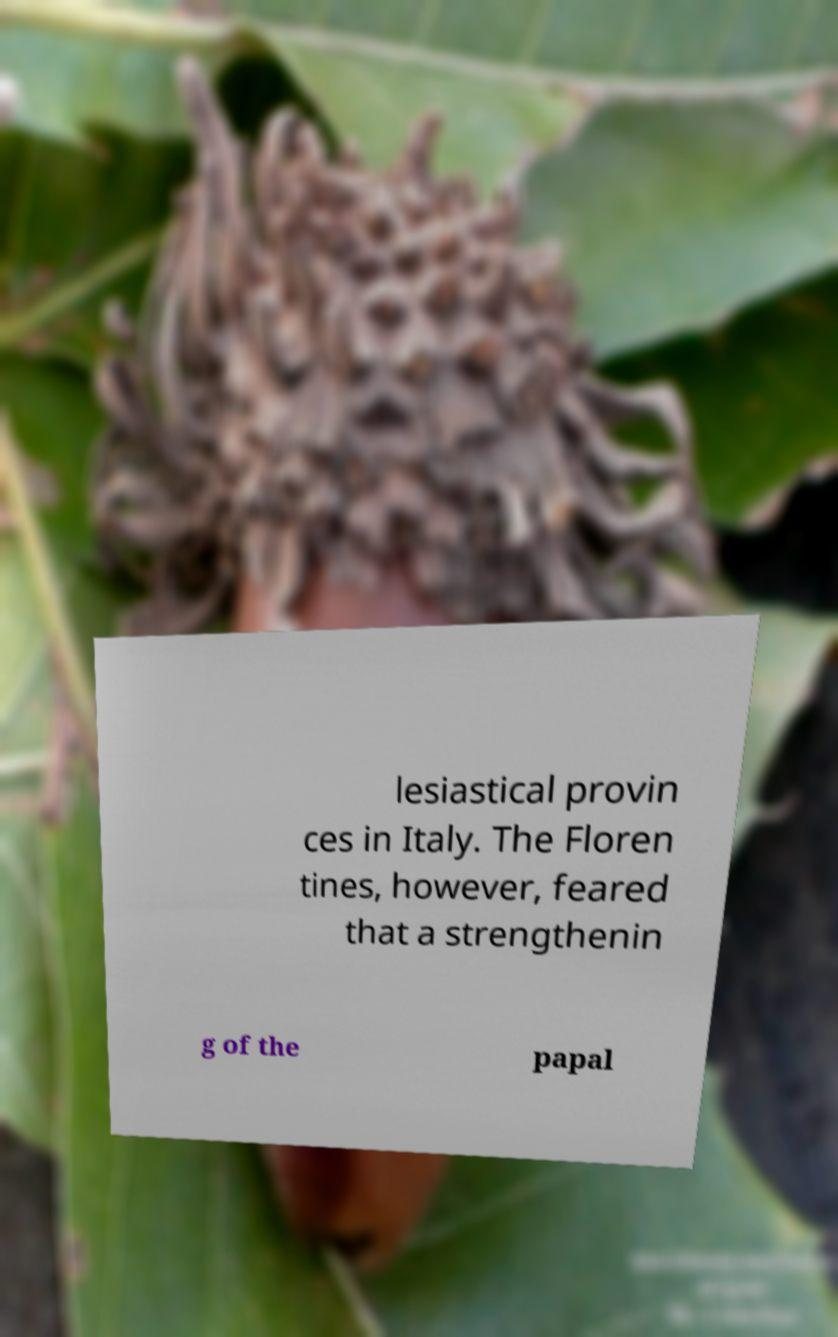Can you read and provide the text displayed in the image?This photo seems to have some interesting text. Can you extract and type it out for me? lesiastical provin ces in Italy. The Floren tines, however, feared that a strengthenin g of the papal 